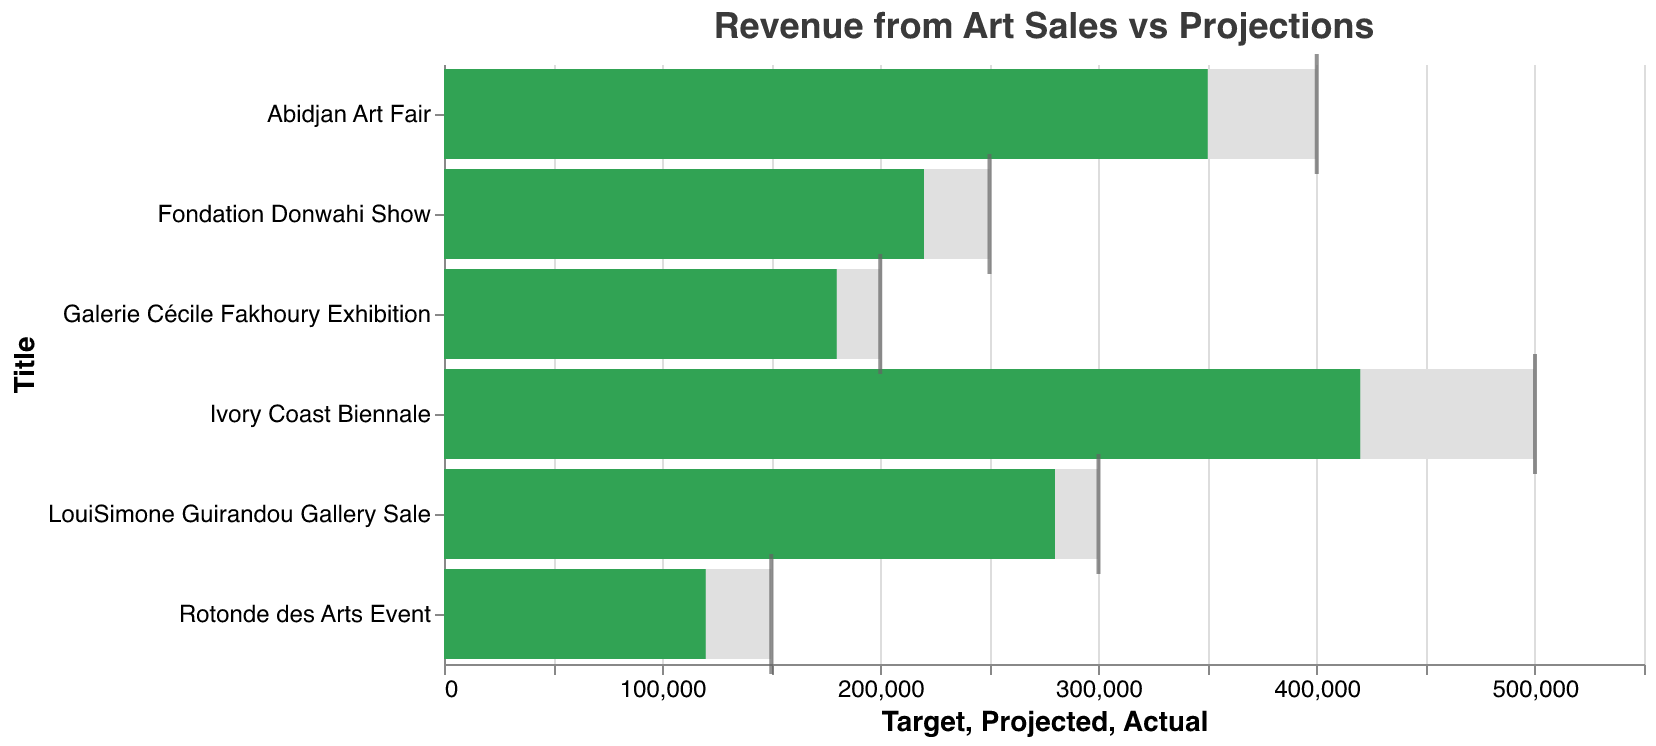Which event has the highest actual revenue? The highest actual revenue can be seen where the longest green bar on the chart is located. In this case, it's the "Ivory Coast Biennale" with a value of 420,000.
Answer: Ivory Coast Biennale What is the projected revenue for the "Galerie Cécile Fakhoury Exhibition"? The light green bar indicates the projected revenue. For "Galerie Cécile Fakhoury Exhibition," it's positioned at 150,000.
Answer: 150,000 Which event had actual revenue that exceeded the target revenue? Compare the green and grey bars. No event's green bar (actual revenue) surpasses the position of its grey bar (target revenue).
Answer: None How much higher is the actual revenue compared to the projected revenue for the "Abidjan Art Fair"? Subtract the projected revenue (300,000) from the actual revenue (350,000). Therefore, 350,000 - 300,000 equals 50,000.
Answer: 50,000 Which event is closest to reaching its target revenue? Look for the smallest gap between the end of the green bar (actual revenue) and the grey tick mark (target revenue). "Ivory Coast Biennale" has an actual revenue of 420,000 and a target of 500,000. The gap is 80,000, which is the smallest among all events.
Answer: Ivory Coast Biennale How many events have actual revenue greater than their projected revenue? Count the number of green bars (actual revenue) that are longer than the light green bars (projected revenue). There are six events in the dataset. The green bar surpasses the light green bar in each case.
Answer: 6 What is the average actual revenue for all events? Sum all actual revenues (350,000 + 180,000 + 220,000 + 120,000 + 280,000 + 420,000) and divide by the number of events (6). The total is 1,570,000, so the average is 1,570,000 / 6.
Answer: 261,666.67 Which event has the smallest difference between actual and projected revenues? Calculate the absolute difference between the actual and projected revenues for each event. "Galerie Cécile Fakhoury Exhibition" has a difference of 30,000, which is the smallest.
Answer: Galerie Cécile Fakhoury Exhibition What is the target revenue for the "LouiSimone Guirandou Gallery Sale"? The grey tick mark indicates the target revenue. For this event, it's positioned at 300,000.
Answer: 300,000 Between "Fondation Donwahi Show" and "Rotonde des Arts Event," which one has a higher actual revenue? Compare the lengths of the green bars for these two events. "Fondation Donwahi Show" has an actual revenue of 220,000, higher than "Rotonde des Arts Event" with 120,000.
Answer: Fondation Donwahi Show 